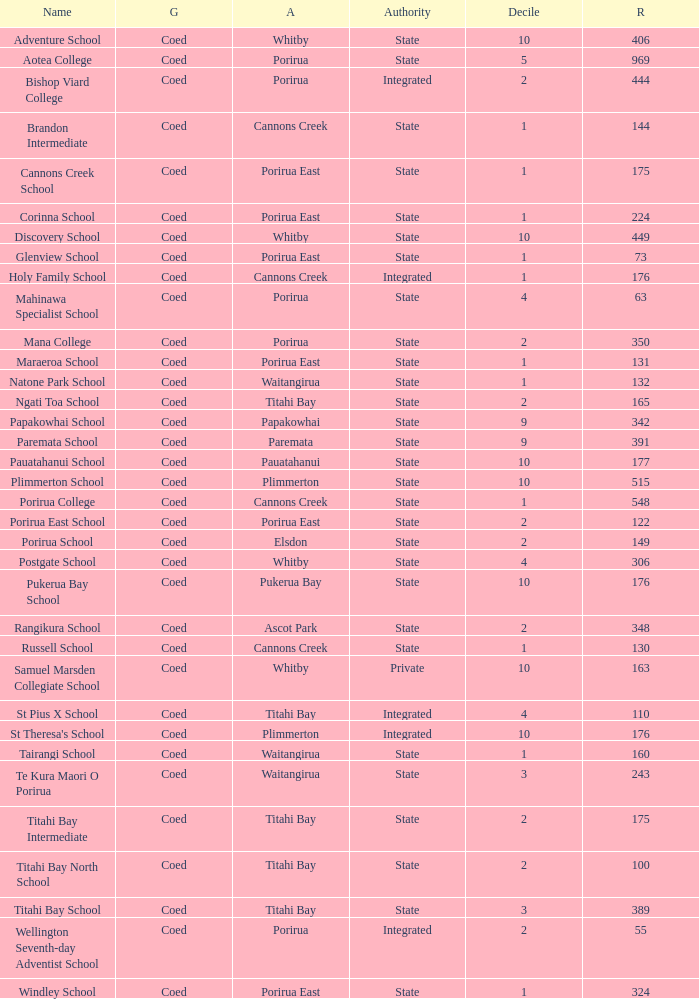What is the roll of Bishop Viard College (An Integrated College), which has a decile larger than 1? 1.0. 